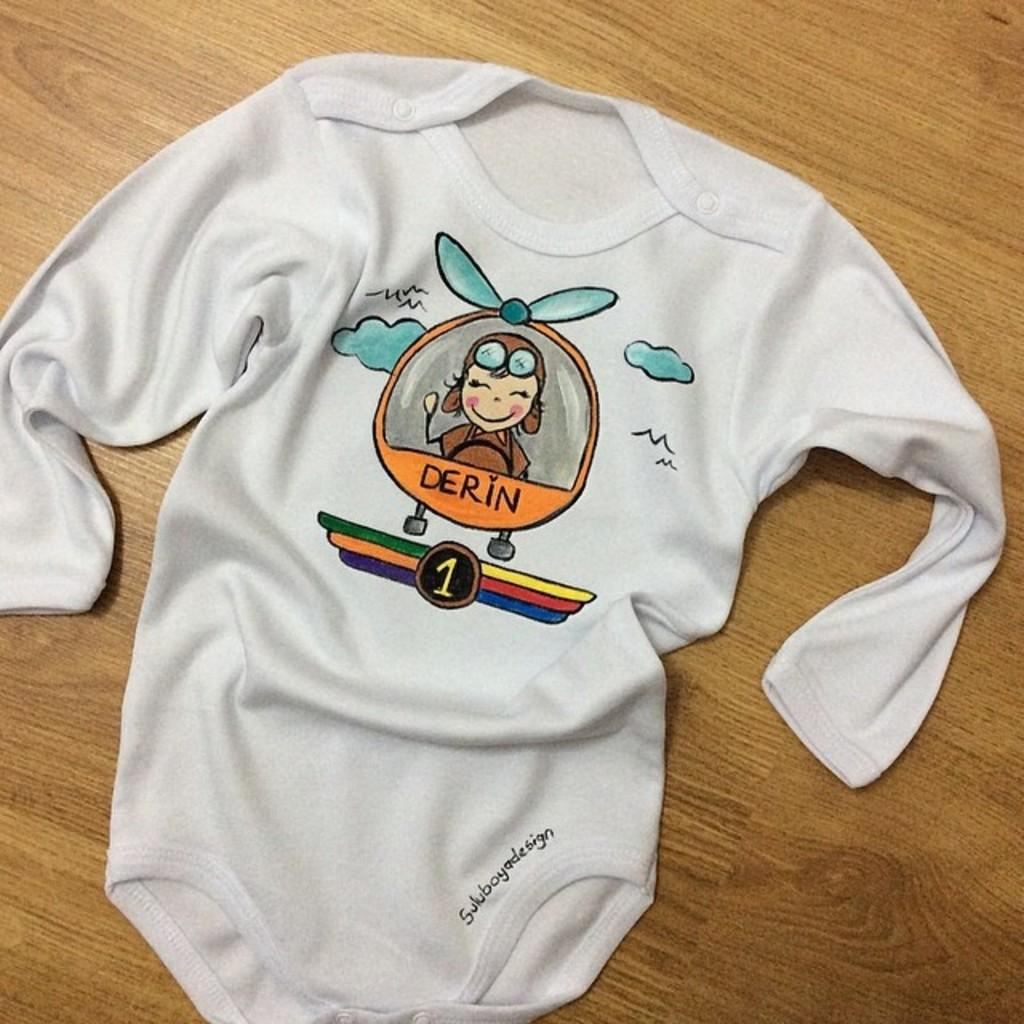What is the color of the cloth in the image? The cloth in the image is white. What is depicted on the cloth? The cloth has a cartoon image on it. Are there any words or letters on the cloth? Yes, there is text written on the cloth. What type of surface is the cloth placed on? The cloth is placed on a wooden surface. What direction is the wind blowing in the image? There is no wind present in the image; it is a still image of a cloth on a wooden surface. 